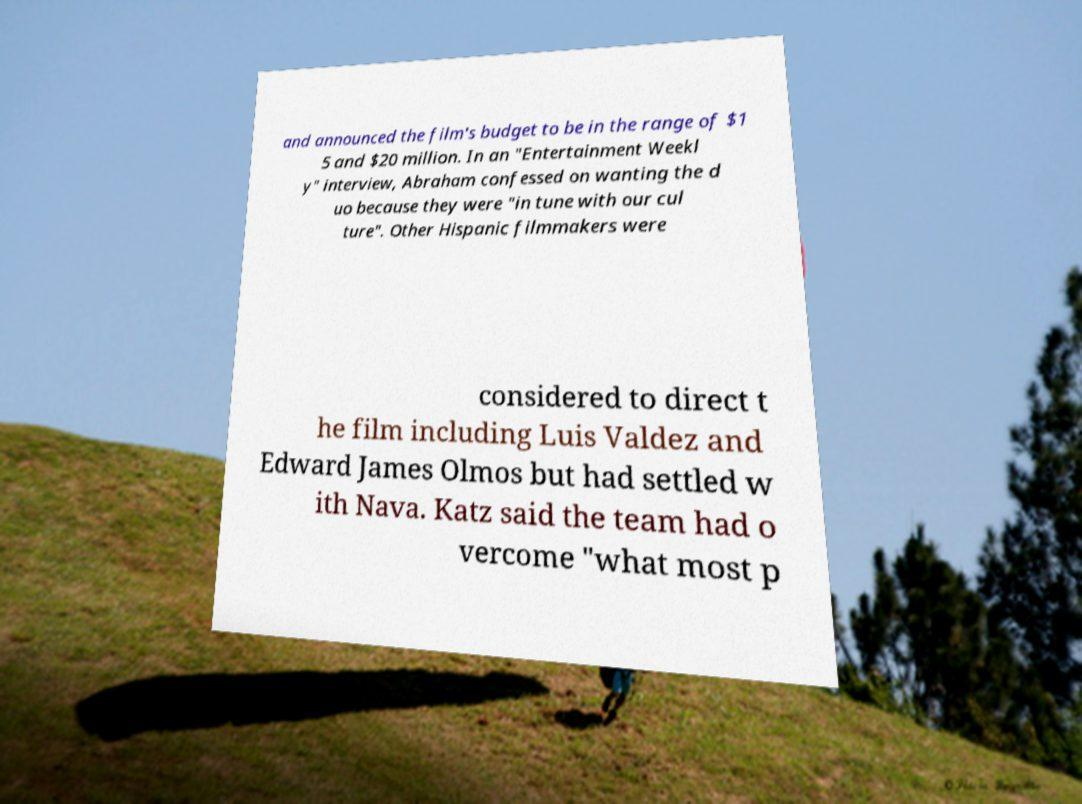There's text embedded in this image that I need extracted. Can you transcribe it verbatim? and announced the film's budget to be in the range of $1 5 and $20 million. In an "Entertainment Weekl y" interview, Abraham confessed on wanting the d uo because they were "in tune with our cul ture". Other Hispanic filmmakers were considered to direct t he film including Luis Valdez and Edward James Olmos but had settled w ith Nava. Katz said the team had o vercome "what most p 